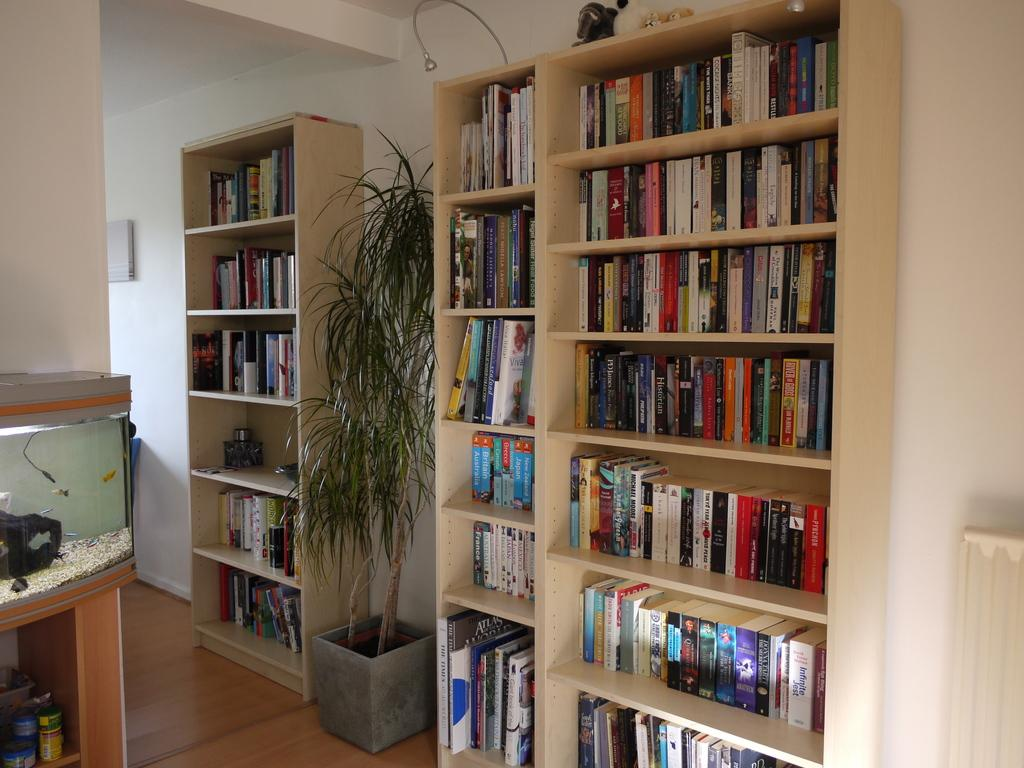What type of storage is shown in the image? There are racks in the image. What items are stored in the racks? There are books kept in the racks. What is the plant placed in? There is a flower pot in the image. What is the plant's purpose in the image? There is a plant in the image. What can be seen behind the racks and the plant? There is a wall visible in the image. What type of zipper can be seen on the plant in the image? There is no zipper present on the plant in the image. What type of railway is visible in the image? There is no railway visible in the image. 